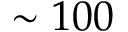<formula> <loc_0><loc_0><loc_500><loc_500>\sim 1 0 0</formula> 